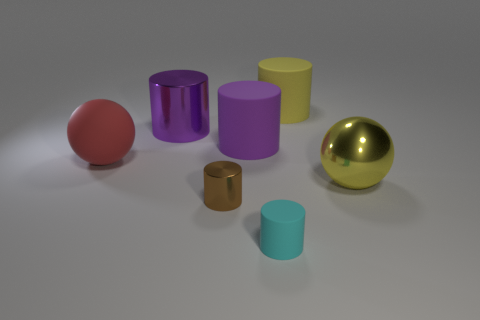What is the small brown thing made of?
Your response must be concise. Metal. What color is the rubber thing to the left of the tiny brown object?
Make the answer very short. Red. What number of large matte blocks have the same color as the metal sphere?
Offer a very short reply. 0. What number of objects are to the right of the red rubber ball and left of the small brown metallic thing?
Your answer should be compact. 1. What shape is the yellow metallic thing that is the same size as the yellow matte cylinder?
Give a very brief answer. Sphere. The yellow shiny sphere has what size?
Offer a terse response. Large. The yellow thing behind the large ball right of the tiny object that is to the right of the brown object is made of what material?
Your answer should be compact. Rubber. There is a ball that is the same material as the tiny brown cylinder; what color is it?
Offer a very short reply. Yellow. How many large purple metal cylinders are on the right side of the small cylinder to the right of the purple cylinder that is on the right side of the small brown shiny cylinder?
Your answer should be very brief. 0. What material is the big object that is the same color as the metallic ball?
Give a very brief answer. Rubber. 